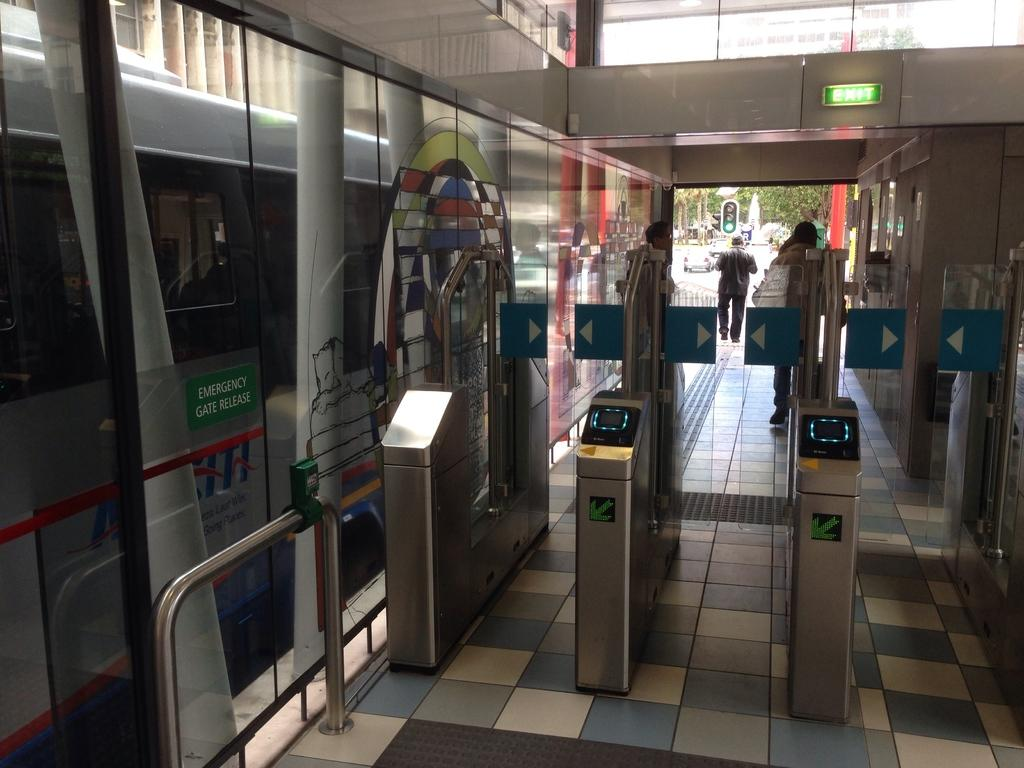<image>
Write a terse but informative summary of the picture. Silver train going by with a sign on the left for emergency gate release 